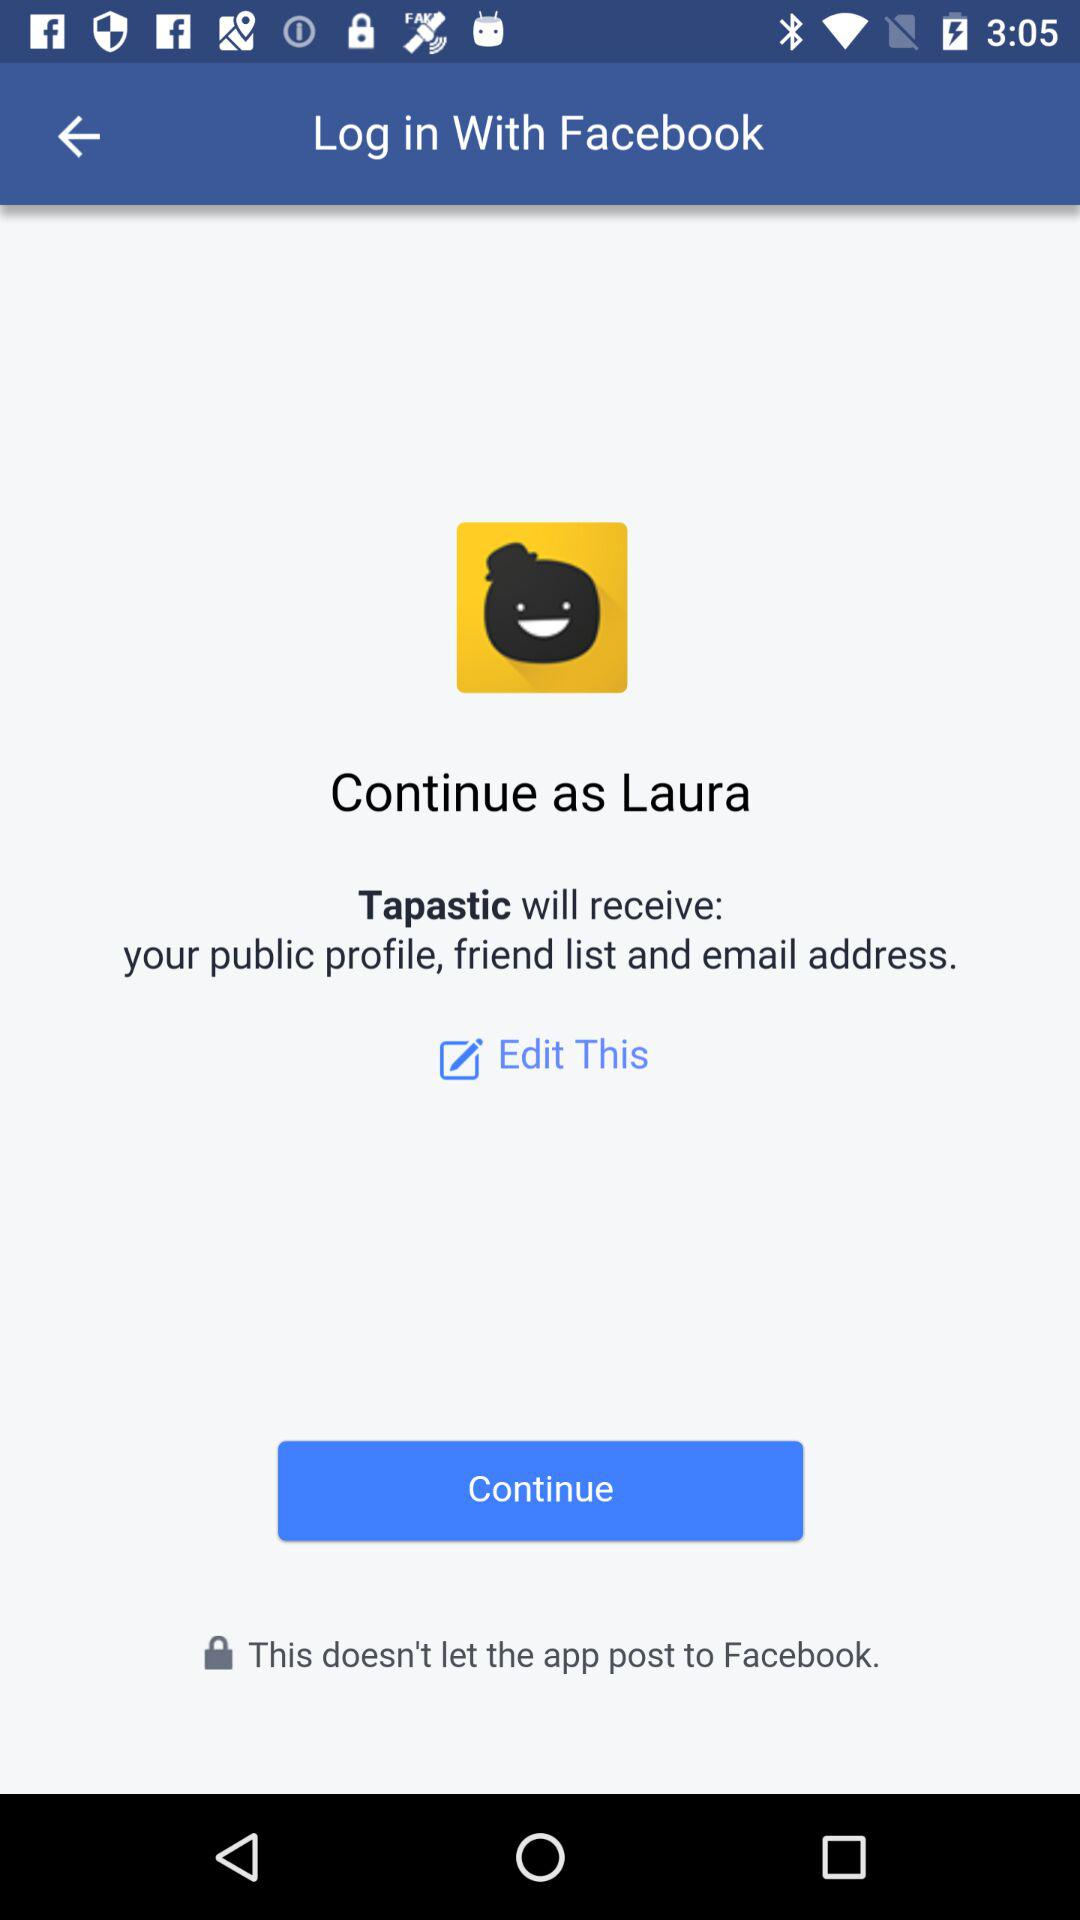What is the login name? The login name is Laura. 